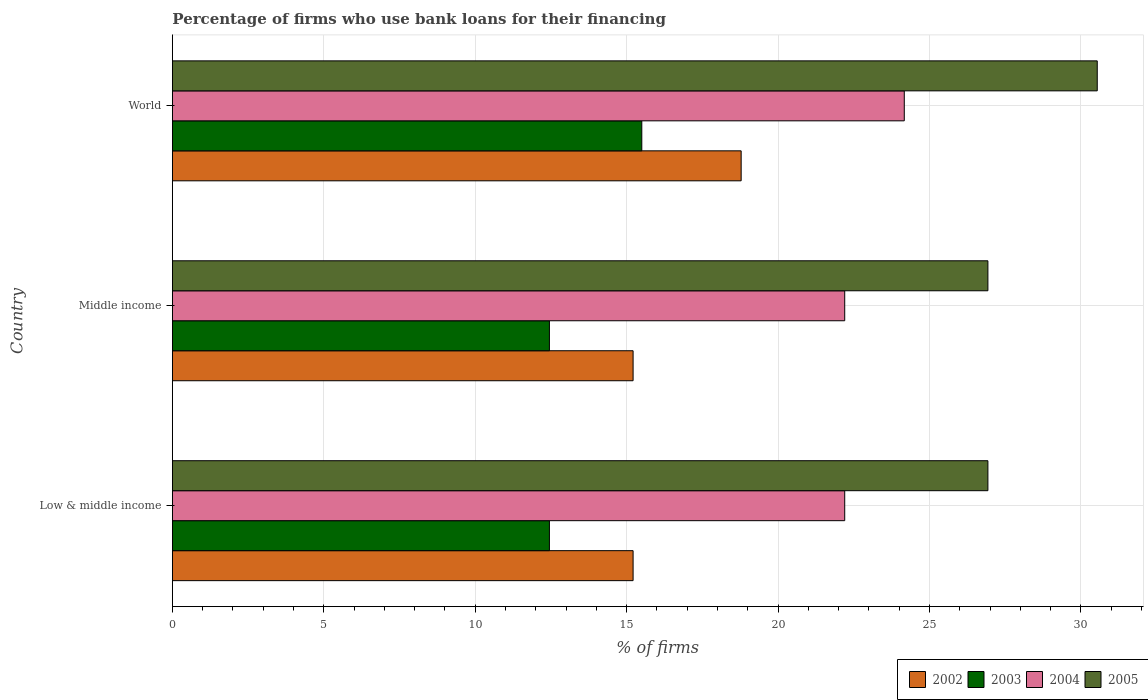Are the number of bars per tick equal to the number of legend labels?
Your answer should be compact. Yes. Are the number of bars on each tick of the Y-axis equal?
Your answer should be compact. Yes. What is the percentage of firms who use bank loans for their financing in 2004 in Low & middle income?
Offer a very short reply. 22.2. Across all countries, what is the minimum percentage of firms who use bank loans for their financing in 2003?
Make the answer very short. 12.45. In which country was the percentage of firms who use bank loans for their financing in 2005 maximum?
Your answer should be very brief. World. In which country was the percentage of firms who use bank loans for their financing in 2005 minimum?
Provide a short and direct response. Low & middle income. What is the total percentage of firms who use bank loans for their financing in 2004 in the graph?
Offer a very short reply. 68.57. What is the difference between the percentage of firms who use bank loans for their financing in 2003 in Low & middle income and that in Middle income?
Ensure brevity in your answer.  0. What is the difference between the percentage of firms who use bank loans for their financing in 2005 in Middle income and the percentage of firms who use bank loans for their financing in 2002 in World?
Offer a very short reply. 8.15. What is the average percentage of firms who use bank loans for their financing in 2002 per country?
Provide a succinct answer. 16.4. What is the difference between the percentage of firms who use bank loans for their financing in 2004 and percentage of firms who use bank loans for their financing in 2003 in Low & middle income?
Your response must be concise. 9.75. In how many countries, is the percentage of firms who use bank loans for their financing in 2004 greater than 6 %?
Provide a short and direct response. 3. What is the ratio of the percentage of firms who use bank loans for their financing in 2004 in Low & middle income to that in World?
Offer a terse response. 0.92. Is the difference between the percentage of firms who use bank loans for their financing in 2004 in Middle income and World greater than the difference between the percentage of firms who use bank loans for their financing in 2003 in Middle income and World?
Keep it short and to the point. Yes. What is the difference between the highest and the second highest percentage of firms who use bank loans for their financing in 2003?
Offer a very short reply. 3.05. What is the difference between the highest and the lowest percentage of firms who use bank loans for their financing in 2005?
Your answer should be very brief. 3.61. In how many countries, is the percentage of firms who use bank loans for their financing in 2005 greater than the average percentage of firms who use bank loans for their financing in 2005 taken over all countries?
Your answer should be compact. 1. Is the sum of the percentage of firms who use bank loans for their financing in 2003 in Middle income and World greater than the maximum percentage of firms who use bank loans for their financing in 2002 across all countries?
Ensure brevity in your answer.  Yes. Is it the case that in every country, the sum of the percentage of firms who use bank loans for their financing in 2003 and percentage of firms who use bank loans for their financing in 2005 is greater than the percentage of firms who use bank loans for their financing in 2004?
Provide a succinct answer. Yes. How many bars are there?
Give a very brief answer. 12. Are all the bars in the graph horizontal?
Offer a very short reply. Yes. What is the difference between two consecutive major ticks on the X-axis?
Offer a terse response. 5. Does the graph contain any zero values?
Ensure brevity in your answer.  No. Does the graph contain grids?
Your answer should be compact. Yes. How are the legend labels stacked?
Offer a terse response. Horizontal. What is the title of the graph?
Ensure brevity in your answer.  Percentage of firms who use bank loans for their financing. Does "1966" appear as one of the legend labels in the graph?
Ensure brevity in your answer.  No. What is the label or title of the X-axis?
Your answer should be compact. % of firms. What is the label or title of the Y-axis?
Make the answer very short. Country. What is the % of firms of 2002 in Low & middle income?
Keep it short and to the point. 15.21. What is the % of firms of 2003 in Low & middle income?
Ensure brevity in your answer.  12.45. What is the % of firms of 2005 in Low & middle income?
Provide a short and direct response. 26.93. What is the % of firms of 2002 in Middle income?
Your answer should be compact. 15.21. What is the % of firms in 2003 in Middle income?
Keep it short and to the point. 12.45. What is the % of firms of 2005 in Middle income?
Offer a very short reply. 26.93. What is the % of firms in 2002 in World?
Ensure brevity in your answer.  18.78. What is the % of firms of 2004 in World?
Make the answer very short. 24.17. What is the % of firms in 2005 in World?
Make the answer very short. 30.54. Across all countries, what is the maximum % of firms of 2002?
Keep it short and to the point. 18.78. Across all countries, what is the maximum % of firms of 2003?
Provide a short and direct response. 15.5. Across all countries, what is the maximum % of firms in 2004?
Your answer should be very brief. 24.17. Across all countries, what is the maximum % of firms of 2005?
Make the answer very short. 30.54. Across all countries, what is the minimum % of firms of 2002?
Keep it short and to the point. 15.21. Across all countries, what is the minimum % of firms in 2003?
Keep it short and to the point. 12.45. Across all countries, what is the minimum % of firms in 2005?
Make the answer very short. 26.93. What is the total % of firms of 2002 in the graph?
Give a very brief answer. 49.21. What is the total % of firms of 2003 in the graph?
Give a very brief answer. 40.4. What is the total % of firms in 2004 in the graph?
Give a very brief answer. 68.57. What is the total % of firms of 2005 in the graph?
Make the answer very short. 84.39. What is the difference between the % of firms in 2003 in Low & middle income and that in Middle income?
Offer a terse response. 0. What is the difference between the % of firms of 2004 in Low & middle income and that in Middle income?
Your answer should be compact. 0. What is the difference between the % of firms of 2005 in Low & middle income and that in Middle income?
Your answer should be very brief. 0. What is the difference between the % of firms in 2002 in Low & middle income and that in World?
Provide a short and direct response. -3.57. What is the difference between the % of firms of 2003 in Low & middle income and that in World?
Make the answer very short. -3.05. What is the difference between the % of firms of 2004 in Low & middle income and that in World?
Keep it short and to the point. -1.97. What is the difference between the % of firms in 2005 in Low & middle income and that in World?
Ensure brevity in your answer.  -3.61. What is the difference between the % of firms in 2002 in Middle income and that in World?
Give a very brief answer. -3.57. What is the difference between the % of firms in 2003 in Middle income and that in World?
Offer a very short reply. -3.05. What is the difference between the % of firms of 2004 in Middle income and that in World?
Provide a short and direct response. -1.97. What is the difference between the % of firms in 2005 in Middle income and that in World?
Give a very brief answer. -3.61. What is the difference between the % of firms of 2002 in Low & middle income and the % of firms of 2003 in Middle income?
Provide a succinct answer. 2.76. What is the difference between the % of firms in 2002 in Low & middle income and the % of firms in 2004 in Middle income?
Provide a succinct answer. -6.99. What is the difference between the % of firms in 2002 in Low & middle income and the % of firms in 2005 in Middle income?
Give a very brief answer. -11.72. What is the difference between the % of firms in 2003 in Low & middle income and the % of firms in 2004 in Middle income?
Provide a short and direct response. -9.75. What is the difference between the % of firms in 2003 in Low & middle income and the % of firms in 2005 in Middle income?
Ensure brevity in your answer.  -14.48. What is the difference between the % of firms in 2004 in Low & middle income and the % of firms in 2005 in Middle income?
Keep it short and to the point. -4.73. What is the difference between the % of firms in 2002 in Low & middle income and the % of firms in 2003 in World?
Make the answer very short. -0.29. What is the difference between the % of firms of 2002 in Low & middle income and the % of firms of 2004 in World?
Provide a succinct answer. -8.95. What is the difference between the % of firms of 2002 in Low & middle income and the % of firms of 2005 in World?
Ensure brevity in your answer.  -15.33. What is the difference between the % of firms of 2003 in Low & middle income and the % of firms of 2004 in World?
Provide a succinct answer. -11.72. What is the difference between the % of firms of 2003 in Low & middle income and the % of firms of 2005 in World?
Offer a terse response. -18.09. What is the difference between the % of firms of 2004 in Low & middle income and the % of firms of 2005 in World?
Offer a terse response. -8.34. What is the difference between the % of firms of 2002 in Middle income and the % of firms of 2003 in World?
Offer a very short reply. -0.29. What is the difference between the % of firms in 2002 in Middle income and the % of firms in 2004 in World?
Give a very brief answer. -8.95. What is the difference between the % of firms of 2002 in Middle income and the % of firms of 2005 in World?
Provide a short and direct response. -15.33. What is the difference between the % of firms of 2003 in Middle income and the % of firms of 2004 in World?
Provide a short and direct response. -11.72. What is the difference between the % of firms of 2003 in Middle income and the % of firms of 2005 in World?
Offer a very short reply. -18.09. What is the difference between the % of firms of 2004 in Middle income and the % of firms of 2005 in World?
Make the answer very short. -8.34. What is the average % of firms of 2002 per country?
Provide a short and direct response. 16.4. What is the average % of firms in 2003 per country?
Give a very brief answer. 13.47. What is the average % of firms in 2004 per country?
Provide a short and direct response. 22.86. What is the average % of firms of 2005 per country?
Your answer should be compact. 28.13. What is the difference between the % of firms of 2002 and % of firms of 2003 in Low & middle income?
Provide a short and direct response. 2.76. What is the difference between the % of firms of 2002 and % of firms of 2004 in Low & middle income?
Give a very brief answer. -6.99. What is the difference between the % of firms in 2002 and % of firms in 2005 in Low & middle income?
Offer a terse response. -11.72. What is the difference between the % of firms of 2003 and % of firms of 2004 in Low & middle income?
Your response must be concise. -9.75. What is the difference between the % of firms of 2003 and % of firms of 2005 in Low & middle income?
Make the answer very short. -14.48. What is the difference between the % of firms of 2004 and % of firms of 2005 in Low & middle income?
Provide a succinct answer. -4.73. What is the difference between the % of firms of 2002 and % of firms of 2003 in Middle income?
Give a very brief answer. 2.76. What is the difference between the % of firms of 2002 and % of firms of 2004 in Middle income?
Your answer should be very brief. -6.99. What is the difference between the % of firms of 2002 and % of firms of 2005 in Middle income?
Keep it short and to the point. -11.72. What is the difference between the % of firms in 2003 and % of firms in 2004 in Middle income?
Keep it short and to the point. -9.75. What is the difference between the % of firms in 2003 and % of firms in 2005 in Middle income?
Offer a terse response. -14.48. What is the difference between the % of firms in 2004 and % of firms in 2005 in Middle income?
Offer a terse response. -4.73. What is the difference between the % of firms of 2002 and % of firms of 2003 in World?
Provide a succinct answer. 3.28. What is the difference between the % of firms in 2002 and % of firms in 2004 in World?
Your response must be concise. -5.39. What is the difference between the % of firms in 2002 and % of firms in 2005 in World?
Provide a short and direct response. -11.76. What is the difference between the % of firms in 2003 and % of firms in 2004 in World?
Keep it short and to the point. -8.67. What is the difference between the % of firms of 2003 and % of firms of 2005 in World?
Provide a succinct answer. -15.04. What is the difference between the % of firms in 2004 and % of firms in 2005 in World?
Your response must be concise. -6.37. What is the ratio of the % of firms of 2004 in Low & middle income to that in Middle income?
Offer a very short reply. 1. What is the ratio of the % of firms of 2005 in Low & middle income to that in Middle income?
Offer a terse response. 1. What is the ratio of the % of firms in 2002 in Low & middle income to that in World?
Give a very brief answer. 0.81. What is the ratio of the % of firms in 2003 in Low & middle income to that in World?
Keep it short and to the point. 0.8. What is the ratio of the % of firms of 2004 in Low & middle income to that in World?
Ensure brevity in your answer.  0.92. What is the ratio of the % of firms in 2005 in Low & middle income to that in World?
Keep it short and to the point. 0.88. What is the ratio of the % of firms in 2002 in Middle income to that in World?
Give a very brief answer. 0.81. What is the ratio of the % of firms in 2003 in Middle income to that in World?
Give a very brief answer. 0.8. What is the ratio of the % of firms in 2004 in Middle income to that in World?
Your answer should be compact. 0.92. What is the ratio of the % of firms in 2005 in Middle income to that in World?
Make the answer very short. 0.88. What is the difference between the highest and the second highest % of firms in 2002?
Ensure brevity in your answer.  3.57. What is the difference between the highest and the second highest % of firms of 2003?
Provide a succinct answer. 3.05. What is the difference between the highest and the second highest % of firms in 2004?
Offer a very short reply. 1.97. What is the difference between the highest and the second highest % of firms of 2005?
Keep it short and to the point. 3.61. What is the difference between the highest and the lowest % of firms of 2002?
Your response must be concise. 3.57. What is the difference between the highest and the lowest % of firms in 2003?
Make the answer very short. 3.05. What is the difference between the highest and the lowest % of firms of 2004?
Keep it short and to the point. 1.97. What is the difference between the highest and the lowest % of firms of 2005?
Keep it short and to the point. 3.61. 